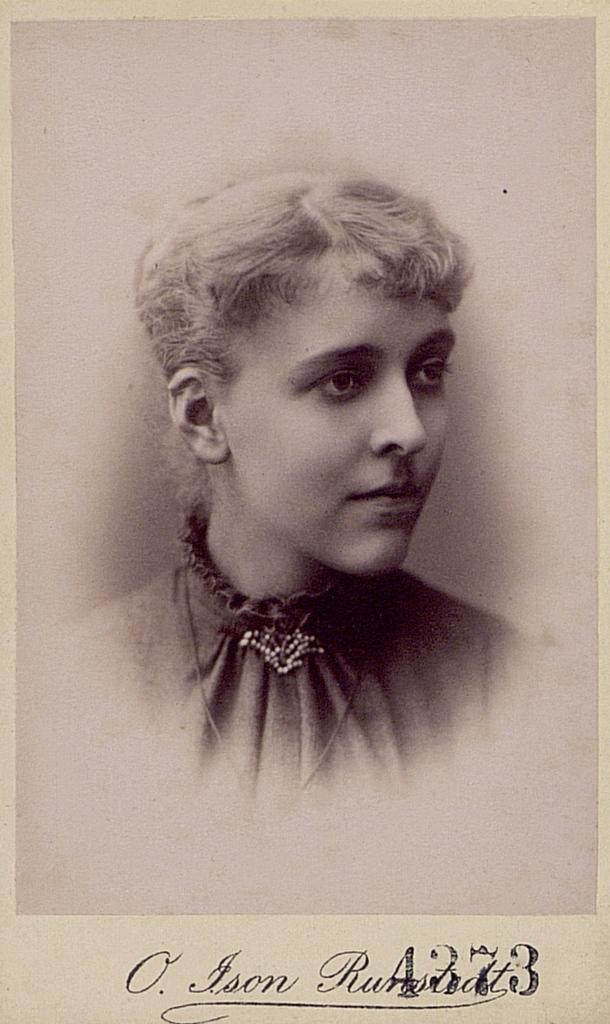In one or two sentences, can you explain what this image depicts? In this image, we can see a poster with some image and text. 